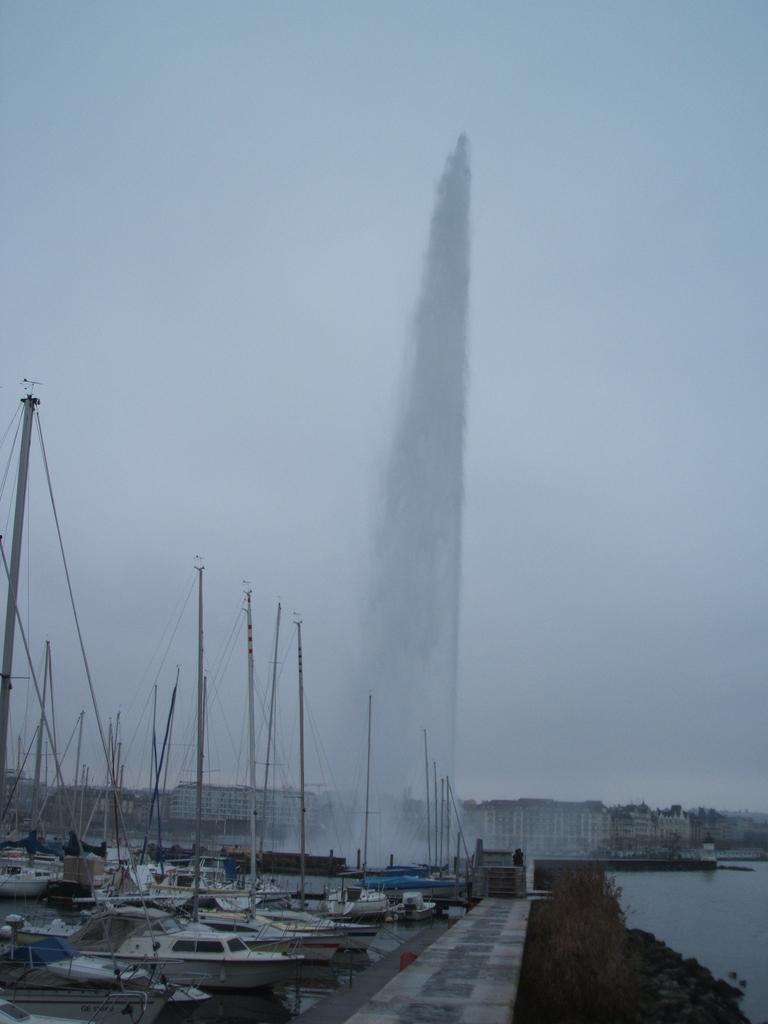Describe this image in one or two sentences. In this image we can see a group of birds with poles and wires in a large water body. We can also see a pathway, stones and some plants. On the backside we can see a group of buildings and the sky which looks cloudy. 